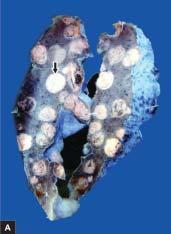does sectioned surface of the lung show replacement of slaty-grey spongy parenchyma with multiple, firm, grey-white nodular masses, some having areas of haemorhages and necrosis?
Answer the question using a single word or phrase. Yes 